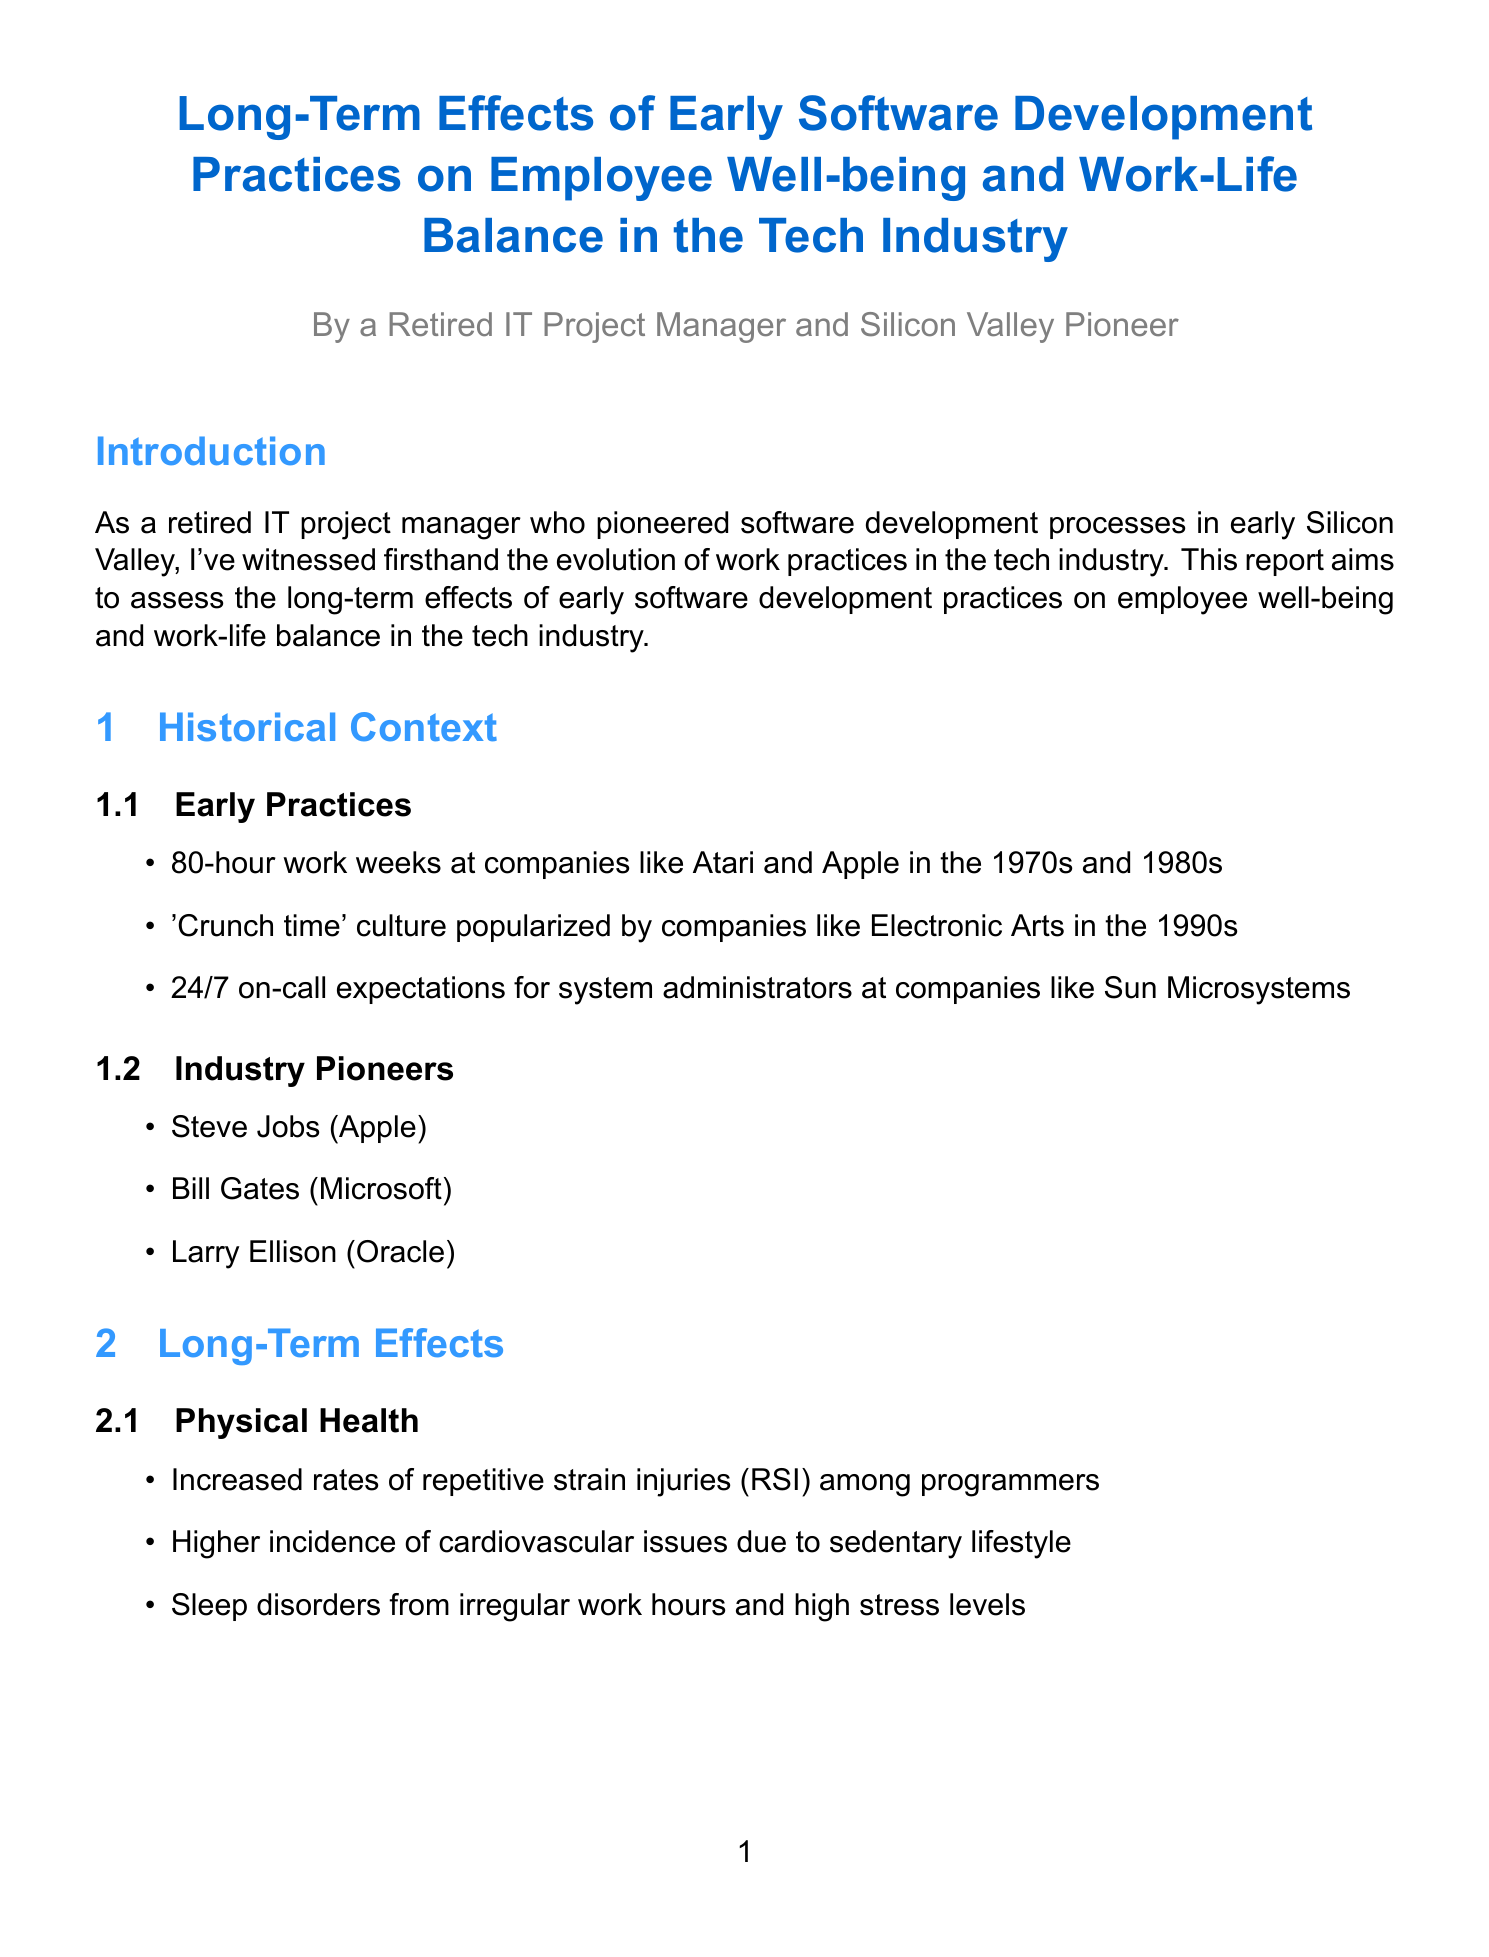What are the early work practices mentioned? The document lists specific early work practices from the tech industry, such as "80-hour work weeks at companies like Atari and Apple in the 1970s and 1980s."
Answer: 80-hour work weeks, 'Crunch time' culture, 24/7 on-call expectations Who is mentioned as a pioneer in the industry? The report lists key figures who contributed significantly to the tech industry's development, including Steve Jobs.
Answer: Steve Jobs What impact did Intel's practice have? The document explains the result of Intel's practice with a specific effect on employee satisfaction.
Answer: Improved employee satisfaction and retention rates How many recommendations are provided in the report? The document outlines several actionable recommendations, and asking about them requires counting.
Answer: Five What is a significant mental health issue highlighted? The report emphasizes a specific mental health issue prevalent among software developers.
Answer: Burnout syndrome What does the report suggest about after-hours communication? Addressing work-life balance, the report recommends a specific guideline for after-hours communication.
Answer: Establish clear boundaries What is a positive change mentioned in the evolution of the industry? The document describes specific improvements made over time regarding work practices in the tech industry, such as flexible work hours.
Answer: Implementation of flexible work hours What does the conclusion summarize about early practices? The document provides a summary statement about the overall implications of early software development practices on employee well-being.
Answer: Significant long-term effects on employee well-being and work-life balance 